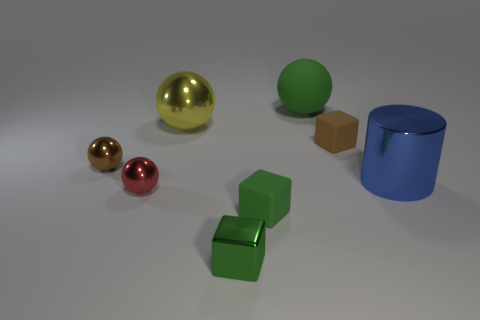There is a green matte block; what number of big objects are to the right of it?
Offer a very short reply. 2. How big is the metal thing that is to the right of the green object that is behind the metal object to the right of the green metallic block?
Offer a very short reply. Large. Are there any matte things that are to the left of the object that is behind the large yellow metallic thing behind the big blue metallic cylinder?
Give a very brief answer. Yes. Is the number of rubber spheres greater than the number of large spheres?
Your answer should be very brief. No. There is a big thing on the left side of the small metal cube; what is its color?
Provide a succinct answer. Yellow. Is the number of small green cubes that are right of the small green metal cube greater than the number of green rubber cylinders?
Your answer should be compact. Yes. Is the material of the yellow object the same as the brown block?
Make the answer very short. No. How many other objects are the same shape as the large blue object?
Offer a terse response. 0. There is a rubber object in front of the rubber object to the right of the green matte thing behind the yellow thing; what is its color?
Keep it short and to the point. Green. Does the small metal thing that is to the right of the large yellow ball have the same shape as the small brown rubber object?
Your answer should be very brief. Yes. 